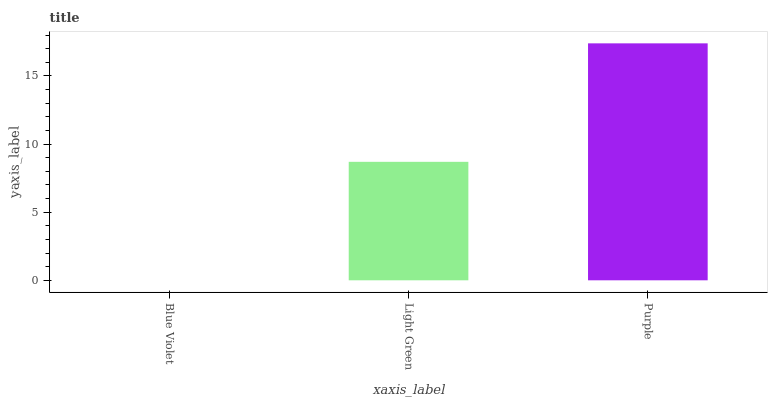Is Blue Violet the minimum?
Answer yes or no. Yes. Is Purple the maximum?
Answer yes or no. Yes. Is Light Green the minimum?
Answer yes or no. No. Is Light Green the maximum?
Answer yes or no. No. Is Light Green greater than Blue Violet?
Answer yes or no. Yes. Is Blue Violet less than Light Green?
Answer yes or no. Yes. Is Blue Violet greater than Light Green?
Answer yes or no. No. Is Light Green less than Blue Violet?
Answer yes or no. No. Is Light Green the high median?
Answer yes or no. Yes. Is Light Green the low median?
Answer yes or no. Yes. Is Purple the high median?
Answer yes or no. No. Is Blue Violet the low median?
Answer yes or no. No. 